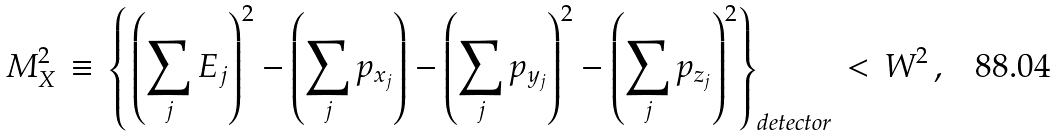<formula> <loc_0><loc_0><loc_500><loc_500>M _ { X } ^ { 2 } \, \equiv \, \left \{ { } \left ( \sum _ { j } E _ { j } \right ) ^ { 2 } - \left ( \sum _ { j } p _ { x _ { j } } \right ) - \left ( \sum _ { j } p _ { y _ { j } } \right ) ^ { 2 } - \left ( \sum _ { j } p _ { z _ { j } } \right ) ^ { 2 } \right \} _ { d e t e c t o r } \, < \, W ^ { 2 } \, ,</formula> 